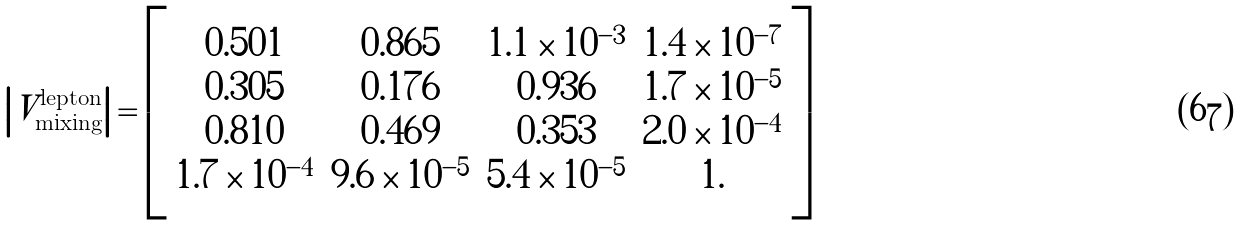<formula> <loc_0><loc_0><loc_500><loc_500>\left | V _ { \text {mixing} } ^ { \text {lepton} } \right | = \left [ \begin{array} { c c c c } 0 . 5 0 1 & 0 . 8 6 5 & 1 . 1 \times 1 0 ^ { - 3 } & 1 . 4 \times 1 0 ^ { - 7 } \\ 0 . 3 0 5 & 0 . 1 7 6 & 0 . 9 3 6 & 1 . 7 \times 1 0 ^ { - 5 } \\ 0 . 8 1 0 & 0 . 4 6 9 & 0 . 3 5 3 & 2 . 0 \times 1 0 ^ { - 4 } \\ 1 . 7 \times 1 0 ^ { - 4 } & 9 . 6 \times 1 0 ^ { - 5 } & 5 . 4 \times 1 0 ^ { - 5 } & 1 . \end{array} \right ]</formula> 